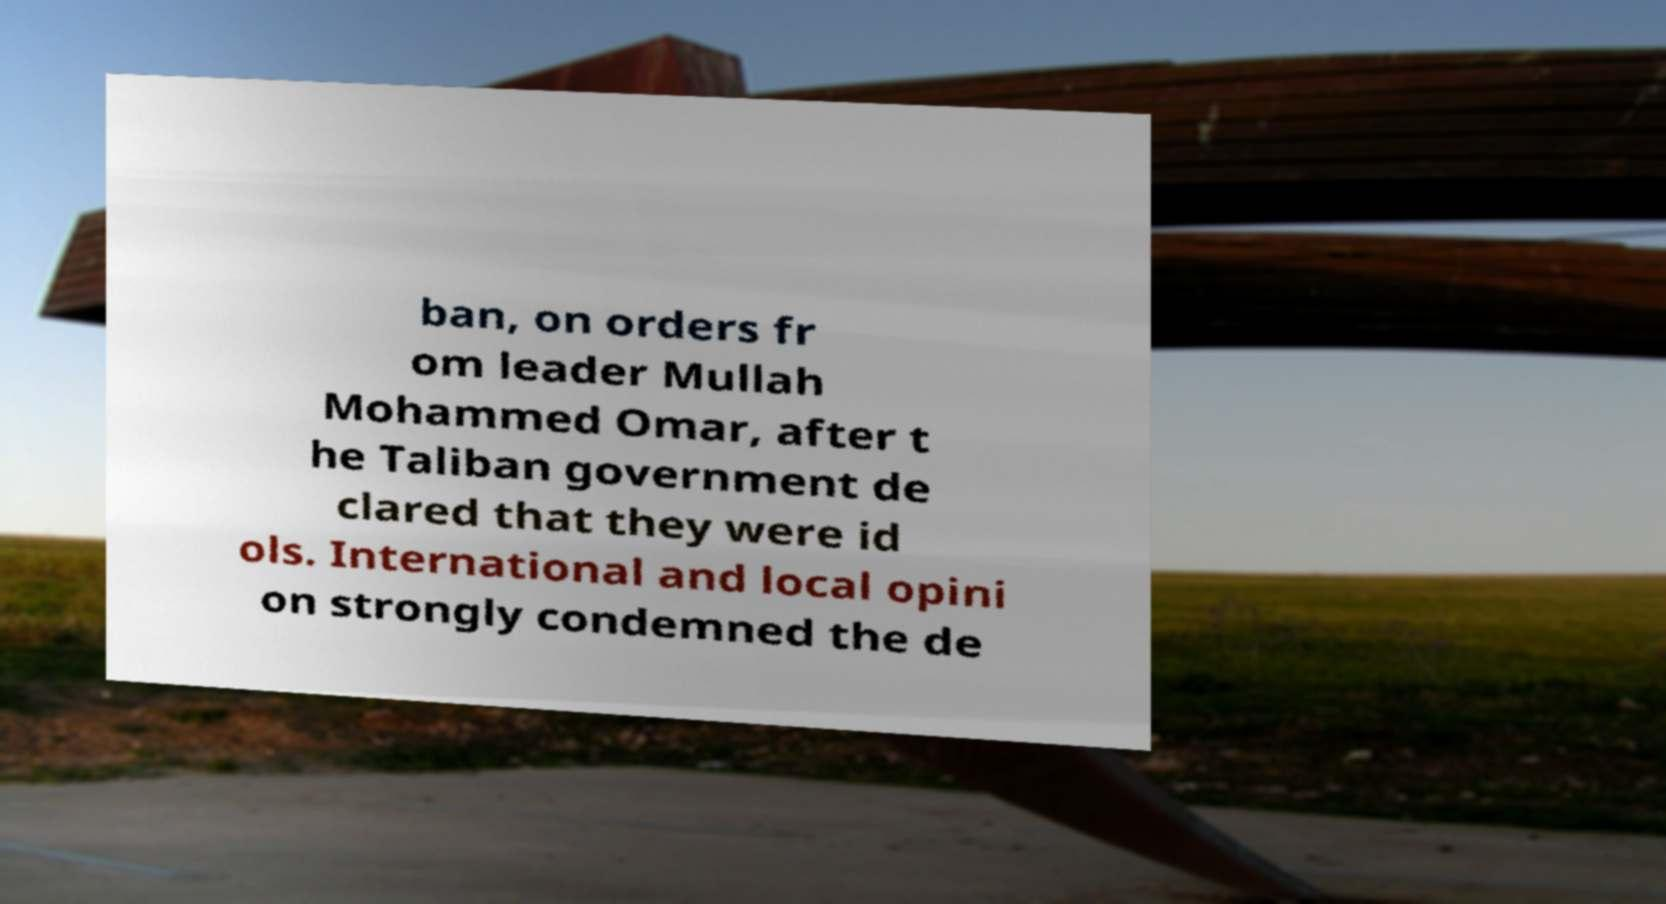I need the written content from this picture converted into text. Can you do that? ban, on orders fr om leader Mullah Mohammed Omar, after t he Taliban government de clared that they were id ols. International and local opini on strongly condemned the de 